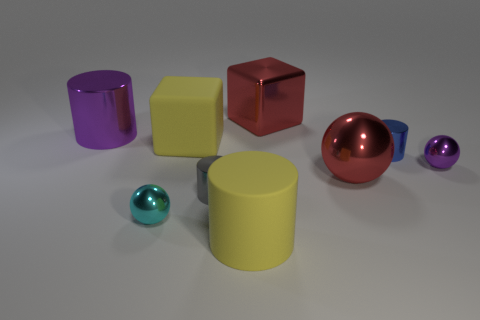Subtract all metallic cylinders. How many cylinders are left? 1 Subtract all spheres. How many objects are left? 6 Subtract all cyan spheres. How many spheres are left? 2 Subtract 1 spheres. How many spheres are left? 2 Add 8 purple shiny spheres. How many purple shiny spheres are left? 9 Add 2 small metallic things. How many small metallic things exist? 6 Subtract 0 cyan cylinders. How many objects are left? 9 Subtract all red cylinders. Subtract all brown blocks. How many cylinders are left? 4 Subtract all yellow metal blocks. Subtract all red things. How many objects are left? 7 